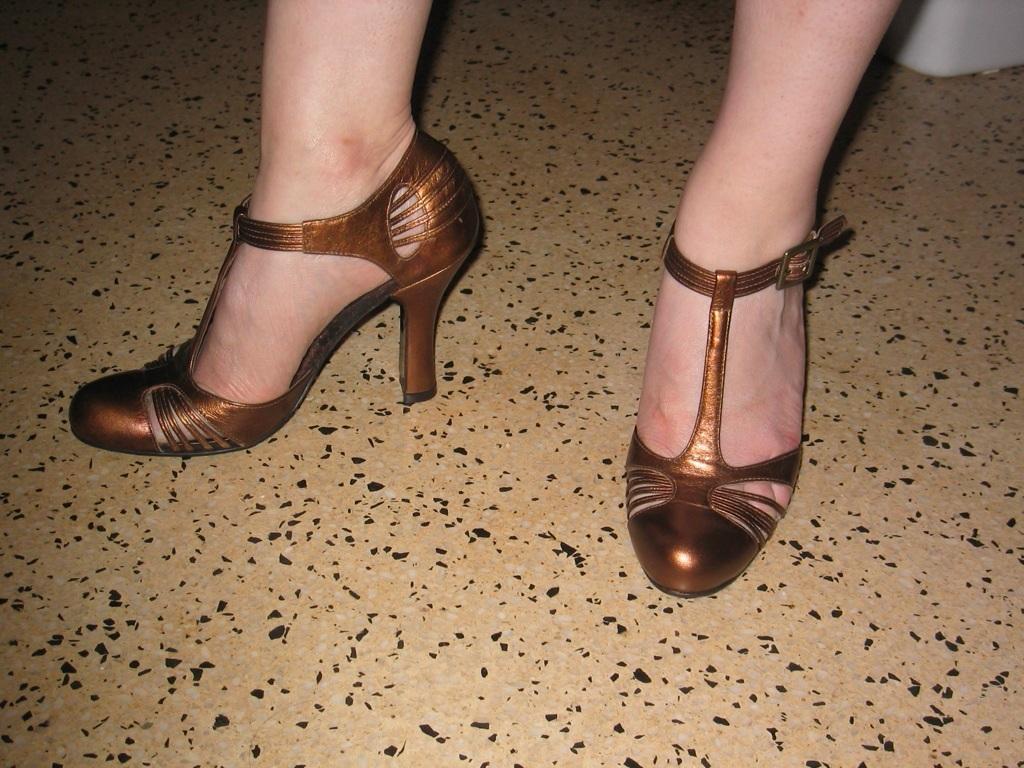Describe this image in one or two sentences. In this image I see the person's legs and I see heels which are of brown in color and I see the floor and I see a white color thing over here. 